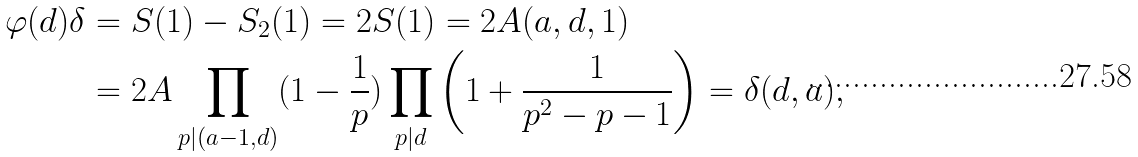<formula> <loc_0><loc_0><loc_500><loc_500>\varphi ( d ) \delta & = S ( 1 ) - S _ { 2 } ( 1 ) = 2 S ( 1 ) = 2 A ( a , d , 1 ) \\ & = 2 A \prod _ { p | ( a - 1 , d ) } ( 1 - \frac { 1 } { p } ) \prod _ { p | d } \left ( 1 + \frac { 1 } { p ^ { 2 } - p - 1 } \right ) = \delta ( d , a ) ,</formula> 